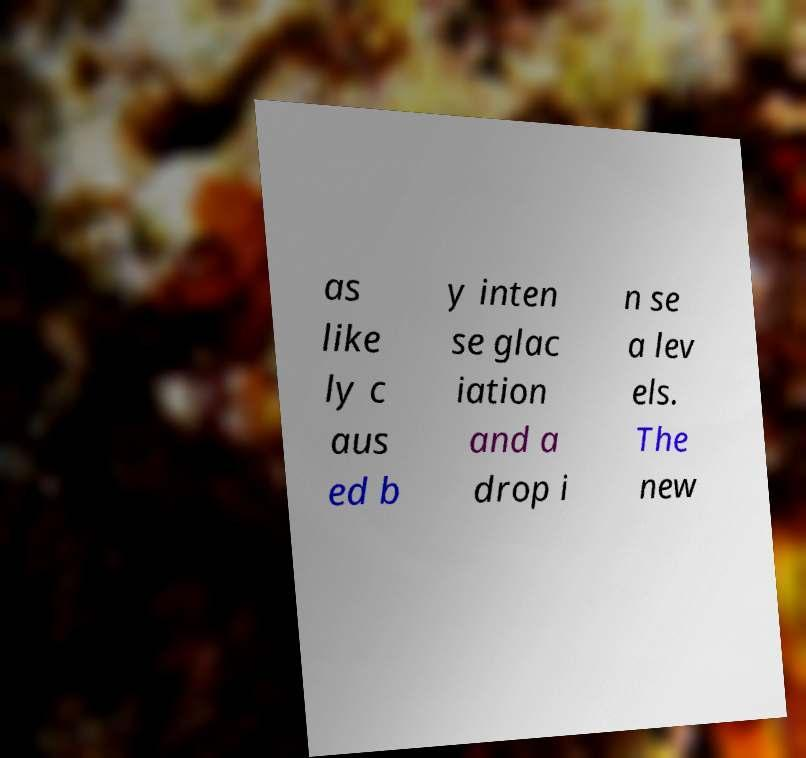There's text embedded in this image that I need extracted. Can you transcribe it verbatim? as like ly c aus ed b y inten se glac iation and a drop i n se a lev els. The new 